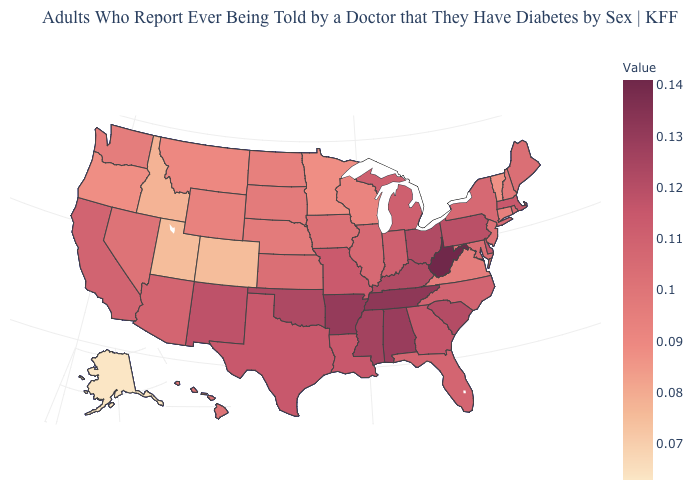Is the legend a continuous bar?
Give a very brief answer. Yes. Which states hav the highest value in the MidWest?
Keep it brief. Ohio. Among the states that border Pennsylvania , which have the lowest value?
Answer briefly. New Jersey. Does Pennsylvania have the lowest value in the USA?
Answer briefly. No. Among the states that border New Jersey , does Pennsylvania have the highest value?
Be succinct. Yes. Does the map have missing data?
Concise answer only. No. Which states hav the highest value in the Northeast?
Be succinct. Pennsylvania. Does the map have missing data?
Keep it brief. No. 